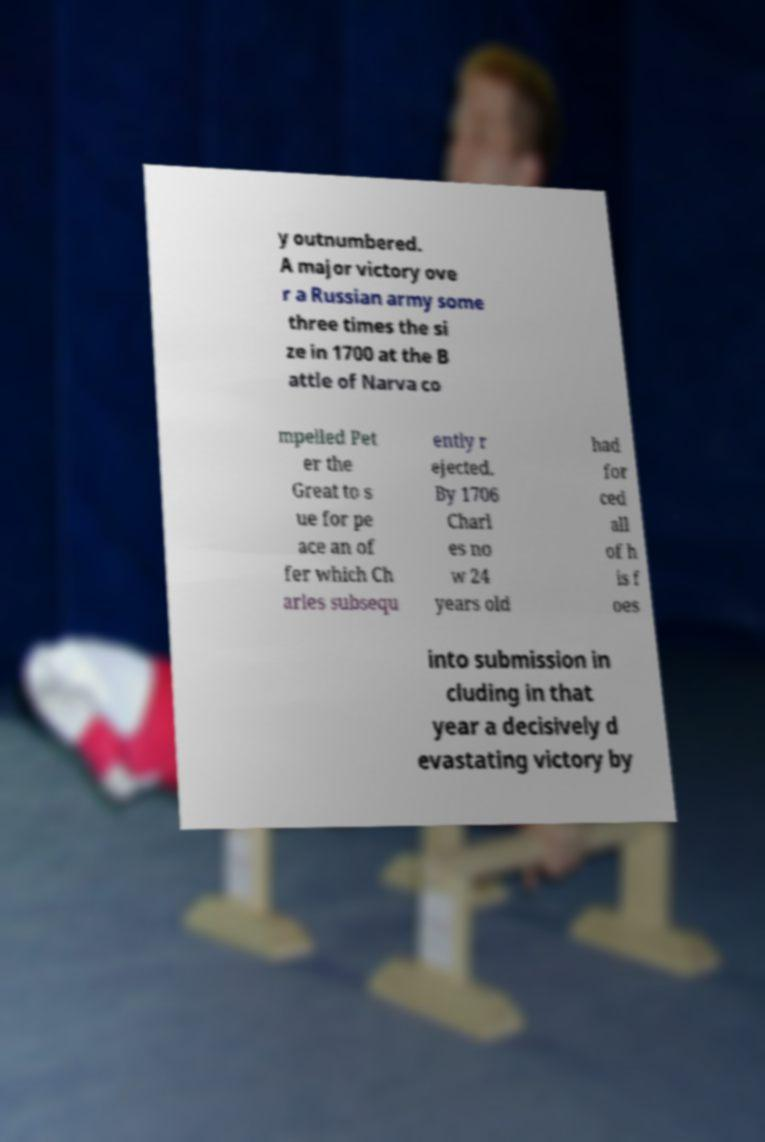I need the written content from this picture converted into text. Can you do that? y outnumbered. A major victory ove r a Russian army some three times the si ze in 1700 at the B attle of Narva co mpelled Pet er the Great to s ue for pe ace an of fer which Ch arles subsequ ently r ejected. By 1706 Charl es no w 24 years old had for ced all of h is f oes into submission in cluding in that year a decisively d evastating victory by 